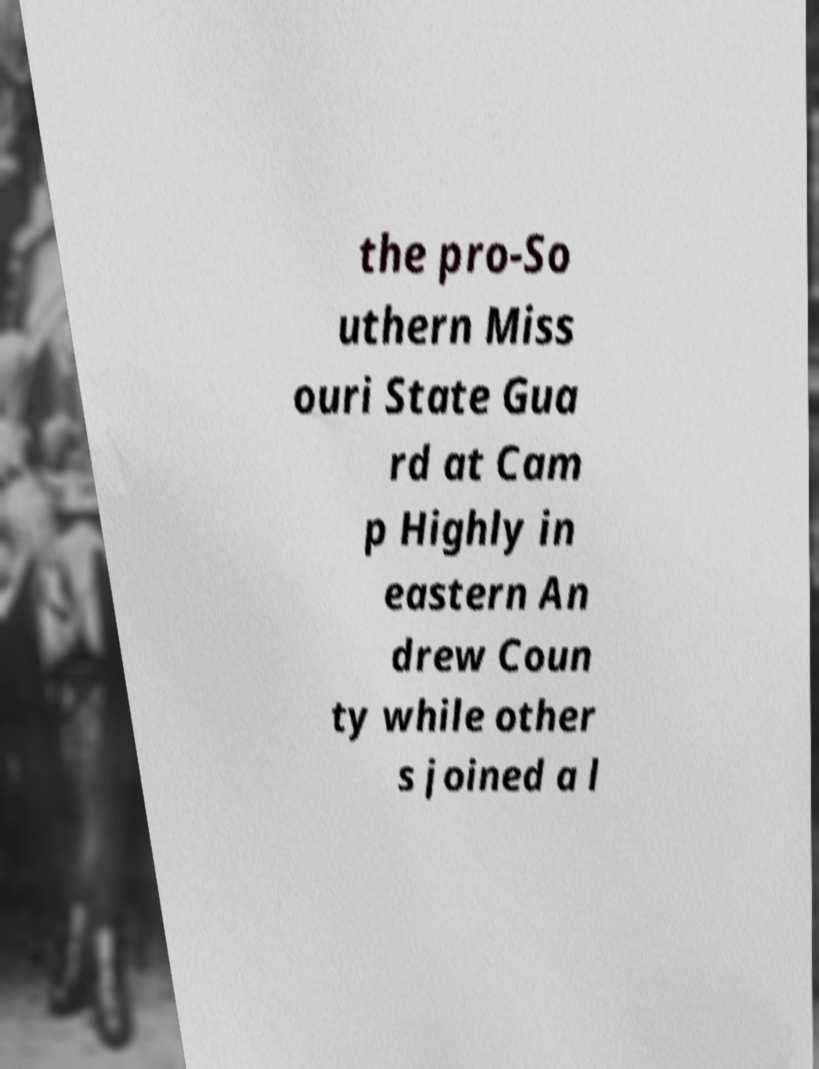Can you accurately transcribe the text from the provided image for me? the pro-So uthern Miss ouri State Gua rd at Cam p Highly in eastern An drew Coun ty while other s joined a l 